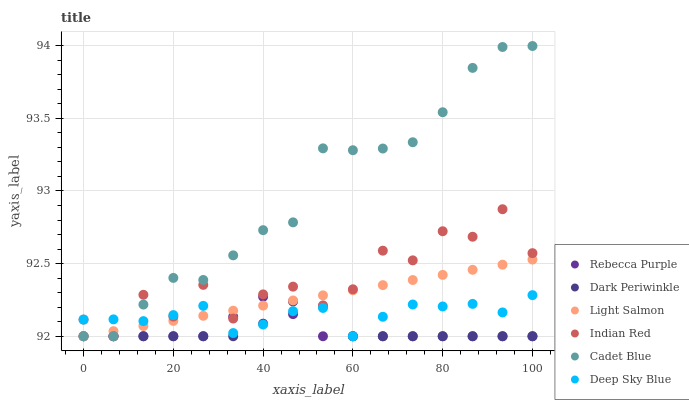Does Dark Periwinkle have the minimum area under the curve?
Answer yes or no. Yes. Does Cadet Blue have the maximum area under the curve?
Answer yes or no. Yes. Does Indian Red have the minimum area under the curve?
Answer yes or no. No. Does Indian Red have the maximum area under the curve?
Answer yes or no. No. Is Light Salmon the smoothest?
Answer yes or no. Yes. Is Indian Red the roughest?
Answer yes or no. Yes. Is Cadet Blue the smoothest?
Answer yes or no. No. Is Cadet Blue the roughest?
Answer yes or no. No. Does Light Salmon have the lowest value?
Answer yes or no. Yes. Does Cadet Blue have the highest value?
Answer yes or no. Yes. Does Indian Red have the highest value?
Answer yes or no. No. Does Deep Sky Blue intersect Rebecca Purple?
Answer yes or no. Yes. Is Deep Sky Blue less than Rebecca Purple?
Answer yes or no. No. Is Deep Sky Blue greater than Rebecca Purple?
Answer yes or no. No. 